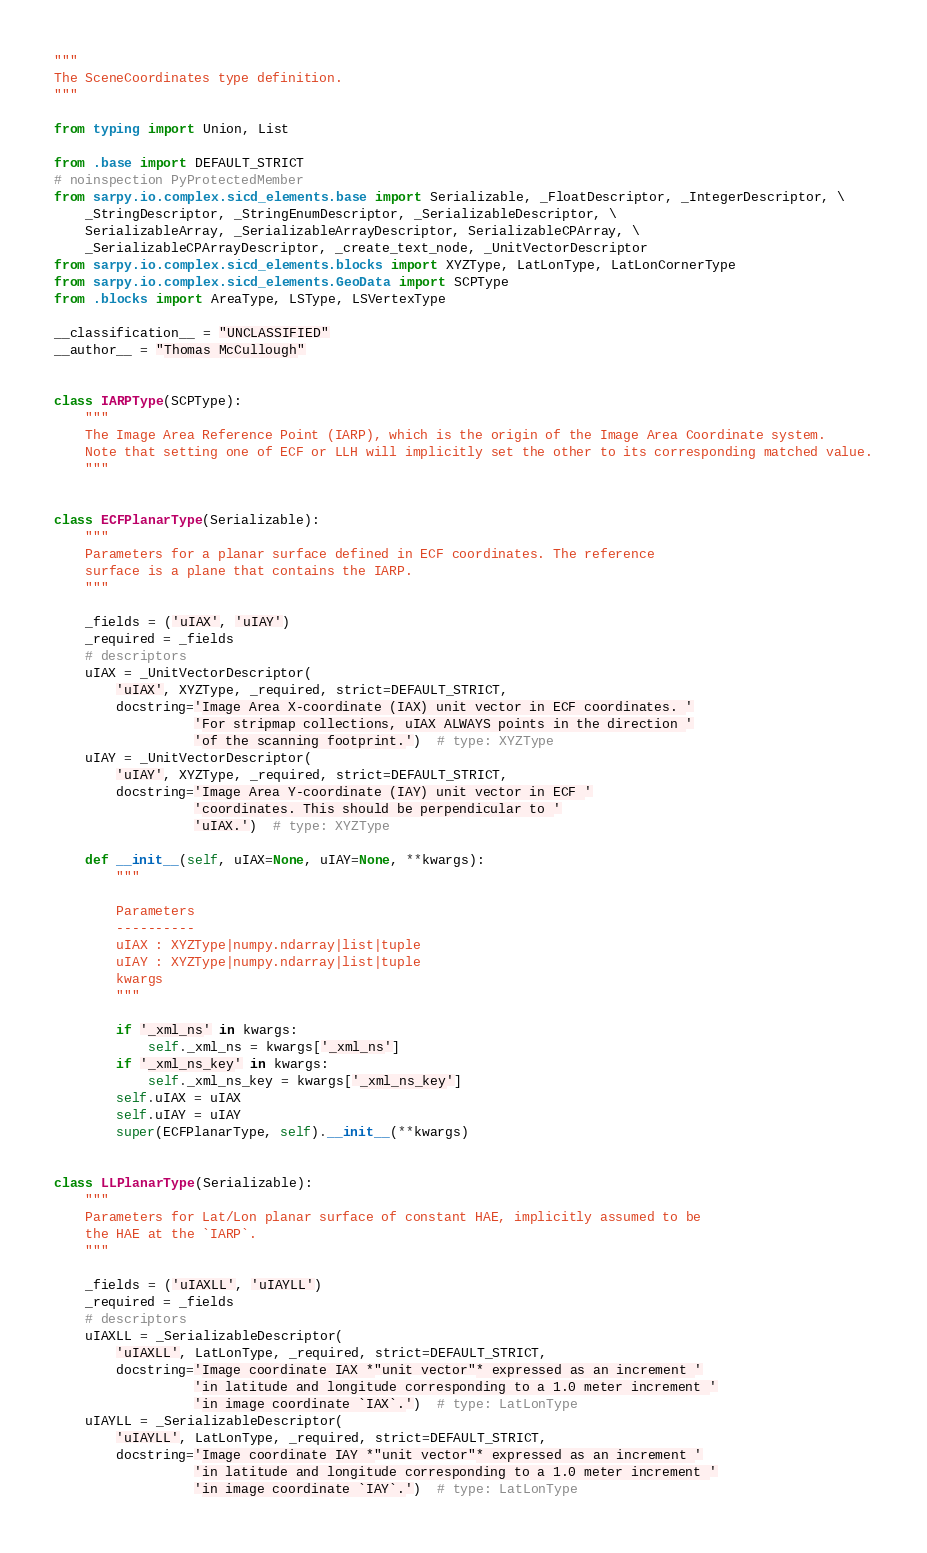<code> <loc_0><loc_0><loc_500><loc_500><_Python_>"""
The SceneCoordinates type definition.
"""

from typing import Union, List

from .base import DEFAULT_STRICT
# noinspection PyProtectedMember
from sarpy.io.complex.sicd_elements.base import Serializable, _FloatDescriptor, _IntegerDescriptor, \
    _StringDescriptor, _StringEnumDescriptor, _SerializableDescriptor, \
    SerializableArray, _SerializableArrayDescriptor, SerializableCPArray, \
    _SerializableCPArrayDescriptor, _create_text_node, _UnitVectorDescriptor
from sarpy.io.complex.sicd_elements.blocks import XYZType, LatLonType, LatLonCornerType
from sarpy.io.complex.sicd_elements.GeoData import SCPType
from .blocks import AreaType, LSType, LSVertexType

__classification__ = "UNCLASSIFIED"
__author__ = "Thomas McCullough"


class IARPType(SCPType):
    """
    The Image Area Reference Point (IARP), which is the origin of the Image Area Coordinate system.
    Note that setting one of ECF or LLH will implicitly set the other to its corresponding matched value.
    """


class ECFPlanarType(Serializable):
    """
    Parameters for a planar surface defined in ECF coordinates. The reference
    surface is a plane that contains the IARP.
    """

    _fields = ('uIAX', 'uIAY')
    _required = _fields
    # descriptors
    uIAX = _UnitVectorDescriptor(
        'uIAX', XYZType, _required, strict=DEFAULT_STRICT,
        docstring='Image Area X-coordinate (IAX) unit vector in ECF coordinates. '
                  'For stripmap collections, uIAX ALWAYS points in the direction '
                  'of the scanning footprint.')  # type: XYZType
    uIAY = _UnitVectorDescriptor(
        'uIAY', XYZType, _required, strict=DEFAULT_STRICT,
        docstring='Image Area Y-coordinate (IAY) unit vector in ECF '
                  'coordinates. This should be perpendicular to '
                  'uIAX.')  # type: XYZType

    def __init__(self, uIAX=None, uIAY=None, **kwargs):
        """

        Parameters
        ----------
        uIAX : XYZType|numpy.ndarray|list|tuple
        uIAY : XYZType|numpy.ndarray|list|tuple
        kwargs
        """

        if '_xml_ns' in kwargs:
            self._xml_ns = kwargs['_xml_ns']
        if '_xml_ns_key' in kwargs:
            self._xml_ns_key = kwargs['_xml_ns_key']
        self.uIAX = uIAX
        self.uIAY = uIAY
        super(ECFPlanarType, self).__init__(**kwargs)


class LLPlanarType(Serializable):
    """
    Parameters for Lat/Lon planar surface of constant HAE, implicitly assumed to be
    the HAE at the `IARP`.
    """

    _fields = ('uIAXLL', 'uIAYLL')
    _required = _fields
    # descriptors
    uIAXLL = _SerializableDescriptor(
        'uIAXLL', LatLonType, _required, strict=DEFAULT_STRICT,
        docstring='Image coordinate IAX *"unit vector"* expressed as an increment '
                  'in latitude and longitude corresponding to a 1.0 meter increment '
                  'in image coordinate `IAX`.')  # type: LatLonType
    uIAYLL = _SerializableDescriptor(
        'uIAYLL', LatLonType, _required, strict=DEFAULT_STRICT,
        docstring='Image coordinate IAY *"unit vector"* expressed as an increment '
                  'in latitude and longitude corresponding to a 1.0 meter increment '
                  'in image coordinate `IAY`.')  # type: LatLonType
</code> 